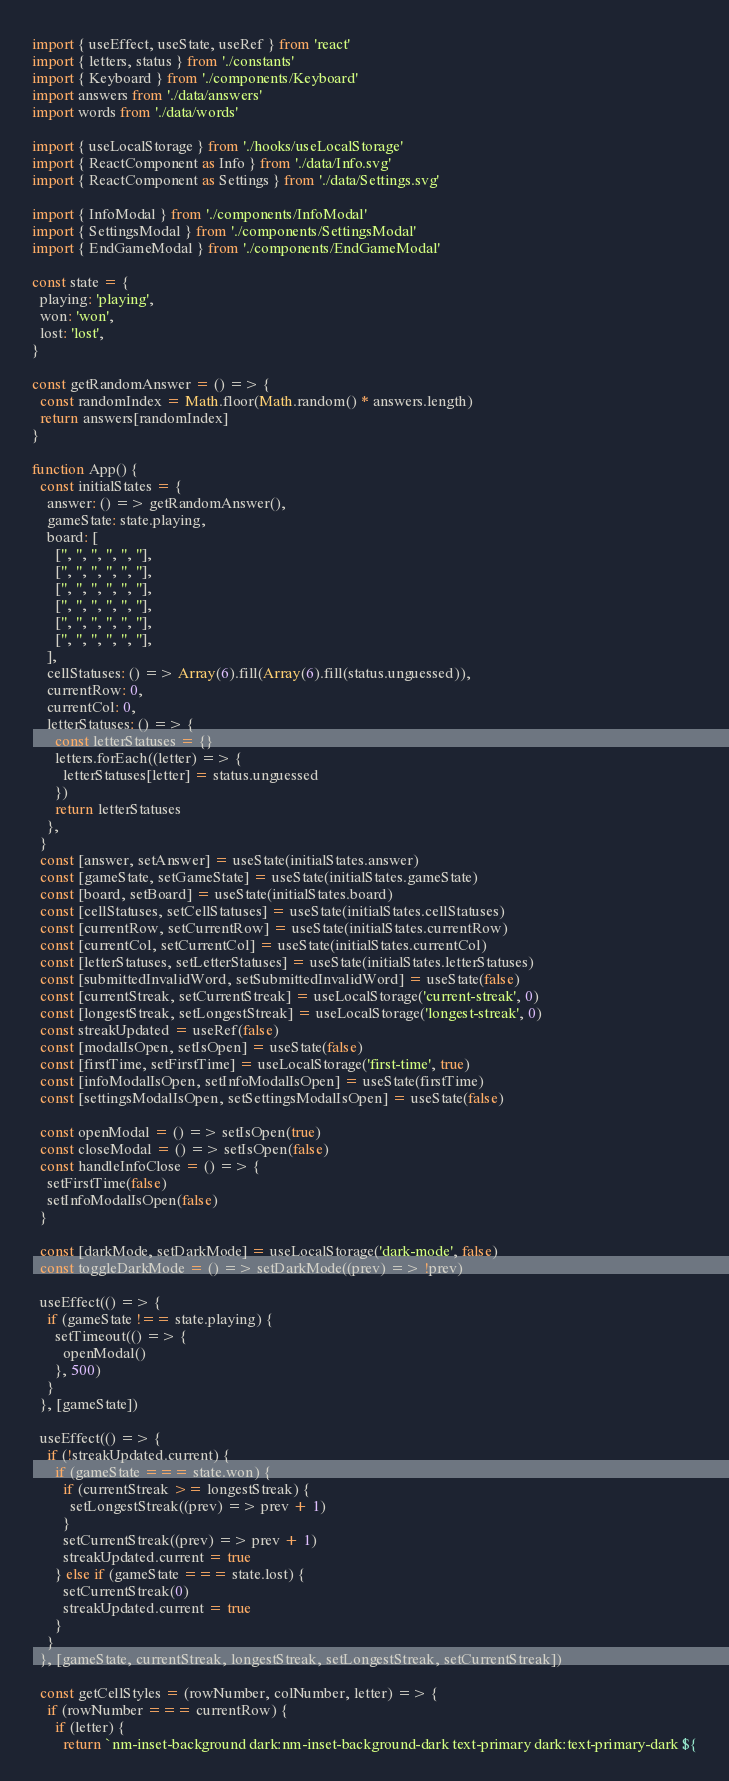<code> <loc_0><loc_0><loc_500><loc_500><_JavaScript_>import { useEffect, useState, useRef } from 'react'
import { letters, status } from './constants'
import { Keyboard } from './components/Keyboard'
import answers from './data/answers'
import words from './data/words'

import { useLocalStorage } from './hooks/useLocalStorage'
import { ReactComponent as Info } from './data/Info.svg'
import { ReactComponent as Settings } from './data/Settings.svg'

import { InfoModal } from './components/InfoModal'
import { SettingsModal } from './components/SettingsModal'
import { EndGameModal } from './components/EndGameModal'

const state = {
  playing: 'playing',
  won: 'won',
  lost: 'lost',
}

const getRandomAnswer = () => {
  const randomIndex = Math.floor(Math.random() * answers.length)
  return answers[randomIndex]
}

function App() {
  const initialStates = {
    answer: () => getRandomAnswer(),
    gameState: state.playing,
    board: [
      ['', '', '', '', '', ''],
      ['', '', '', '', '', ''],
      ['', '', '', '', '', ''],
      ['', '', '', '', '', ''],
      ['', '', '', '', '', ''],
      ['', '', '', '', '', ''],
    ],
    cellStatuses: () => Array(6).fill(Array(6).fill(status.unguessed)),
    currentRow: 0,
    currentCol: 0,
    letterStatuses: () => {
      const letterStatuses = {}
      letters.forEach((letter) => {
        letterStatuses[letter] = status.unguessed
      })
      return letterStatuses
    },
  }
  const [answer, setAnswer] = useState(initialStates.answer)
  const [gameState, setGameState] = useState(initialStates.gameState)
  const [board, setBoard] = useState(initialStates.board)
  const [cellStatuses, setCellStatuses] = useState(initialStates.cellStatuses)
  const [currentRow, setCurrentRow] = useState(initialStates.currentRow)
  const [currentCol, setCurrentCol] = useState(initialStates.currentCol)
  const [letterStatuses, setLetterStatuses] = useState(initialStates.letterStatuses)
  const [submittedInvalidWord, setSubmittedInvalidWord] = useState(false)
  const [currentStreak, setCurrentStreak] = useLocalStorage('current-streak', 0)
  const [longestStreak, setLongestStreak] = useLocalStorage('longest-streak', 0)
  const streakUpdated = useRef(false)
  const [modalIsOpen, setIsOpen] = useState(false)
  const [firstTime, setFirstTime] = useLocalStorage('first-time', true)
  const [infoModalIsOpen, setInfoModalIsOpen] = useState(firstTime)
  const [settingsModalIsOpen, setSettingsModalIsOpen] = useState(false)

  const openModal = () => setIsOpen(true)
  const closeModal = () => setIsOpen(false)
  const handleInfoClose = () => {
    setFirstTime(false)
    setInfoModalIsOpen(false)
  }

  const [darkMode, setDarkMode] = useLocalStorage('dark-mode', false)
  const toggleDarkMode = () => setDarkMode((prev) => !prev)

  useEffect(() => {
    if (gameState !== state.playing) {
      setTimeout(() => {
        openModal()
      }, 500)
    }
  }, [gameState])

  useEffect(() => {
    if (!streakUpdated.current) {
      if (gameState === state.won) {
        if (currentStreak >= longestStreak) {
          setLongestStreak((prev) => prev + 1)
        }
        setCurrentStreak((prev) => prev + 1)
        streakUpdated.current = true
      } else if (gameState === state.lost) {
        setCurrentStreak(0)
        streakUpdated.current = true
      }
    }
  }, [gameState, currentStreak, longestStreak, setLongestStreak, setCurrentStreak])

  const getCellStyles = (rowNumber, colNumber, letter) => {
    if (rowNumber === currentRow) {
      if (letter) {
        return `nm-inset-background dark:nm-inset-background-dark text-primary dark:text-primary-dark ${</code> 